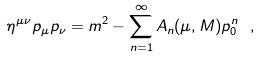<formula> <loc_0><loc_0><loc_500><loc_500>\eta ^ { \mu \nu } p _ { \mu } p _ { \nu } = m ^ { 2 } - \sum _ { n = 1 } ^ { \infty } A _ { n } ( \mu , M ) p _ { 0 } ^ { n } \ ,</formula> 